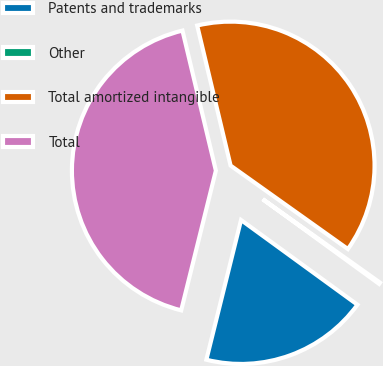Convert chart. <chart><loc_0><loc_0><loc_500><loc_500><pie_chart><fcel>Patents and trademarks<fcel>Other<fcel>Total amortized intangible<fcel>Total<nl><fcel>18.86%<fcel>0.17%<fcel>38.57%<fcel>42.4%<nl></chart> 